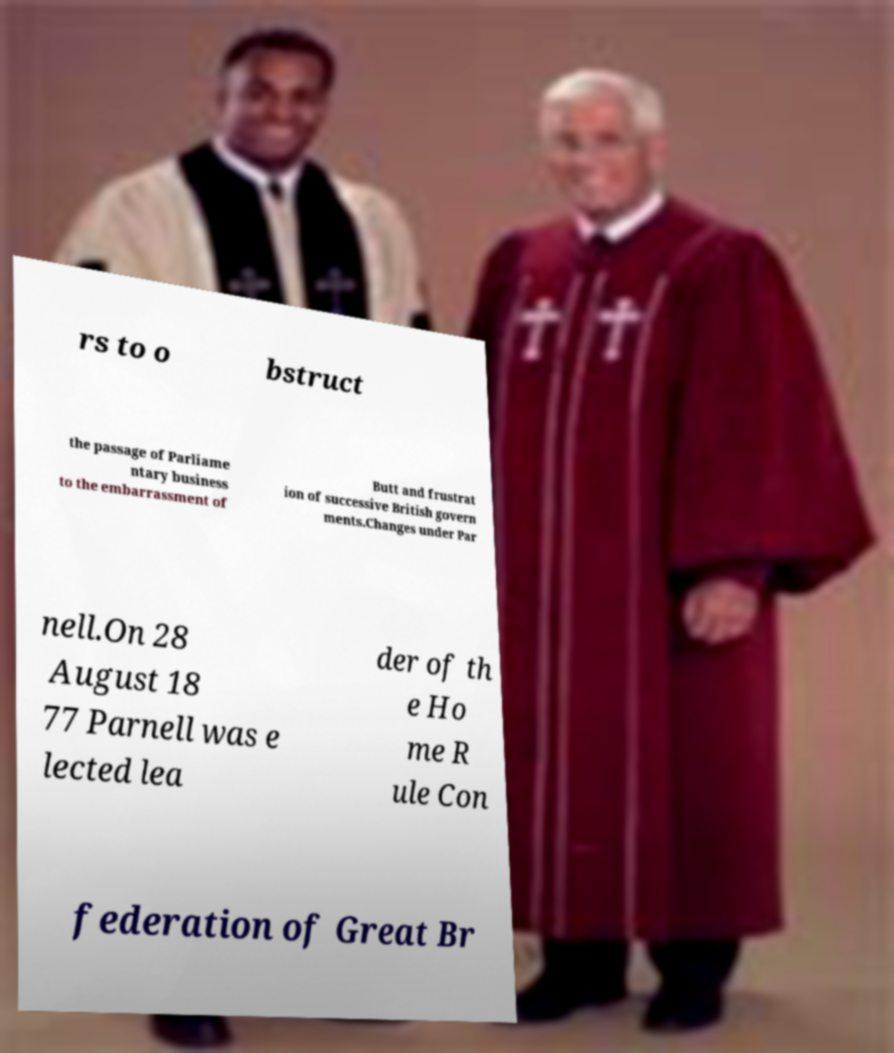Can you read and provide the text displayed in the image?This photo seems to have some interesting text. Can you extract and type it out for me? rs to o bstruct the passage of Parliame ntary business to the embarrassment of Butt and frustrat ion of successive British govern ments.Changes under Par nell.On 28 August 18 77 Parnell was e lected lea der of th e Ho me R ule Con federation of Great Br 